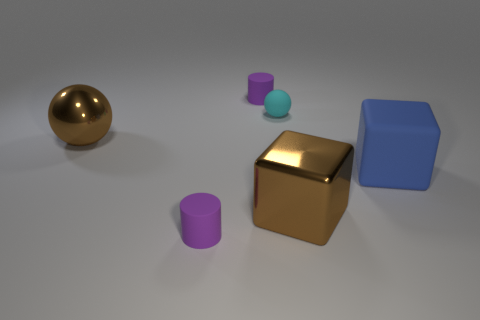If this was a part of a physics experiment, what might be the objective? If this setup was part of a physics experiment, the objective might be to investigate various material properties like reflectivity, since the objects appear to be made of different materials. Or it could be an exercise in understanding geometric optics, by observing the behavior of light and shadows cast by objects of different shapes. 